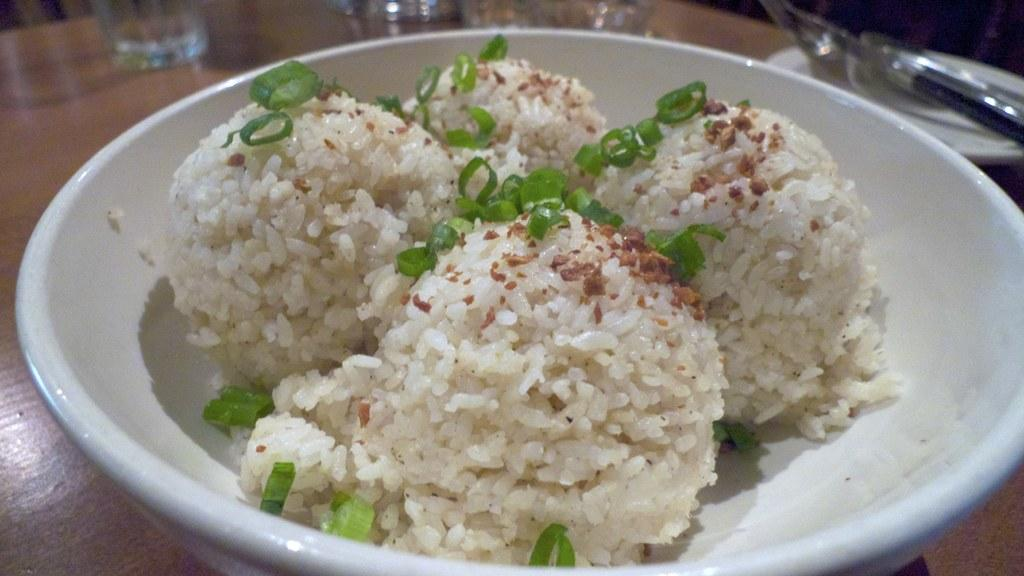What is on the plate that is visible in the image? There is a plate with rice in the image. What is added to the rice to enhance its appearance? The rice is decorated with green vegetables. Where is the plate with rice located? The plate is on a table. What can be seen in the background of the image? There are glasses in the background of the image. What utensils are present on the table in the background? There are spoons in a plate on the table in the background. How far away is the rake from the plate of rice in the image? There is no rake present in the image, so it cannot be determined how far away it would be from the plate of rice. 